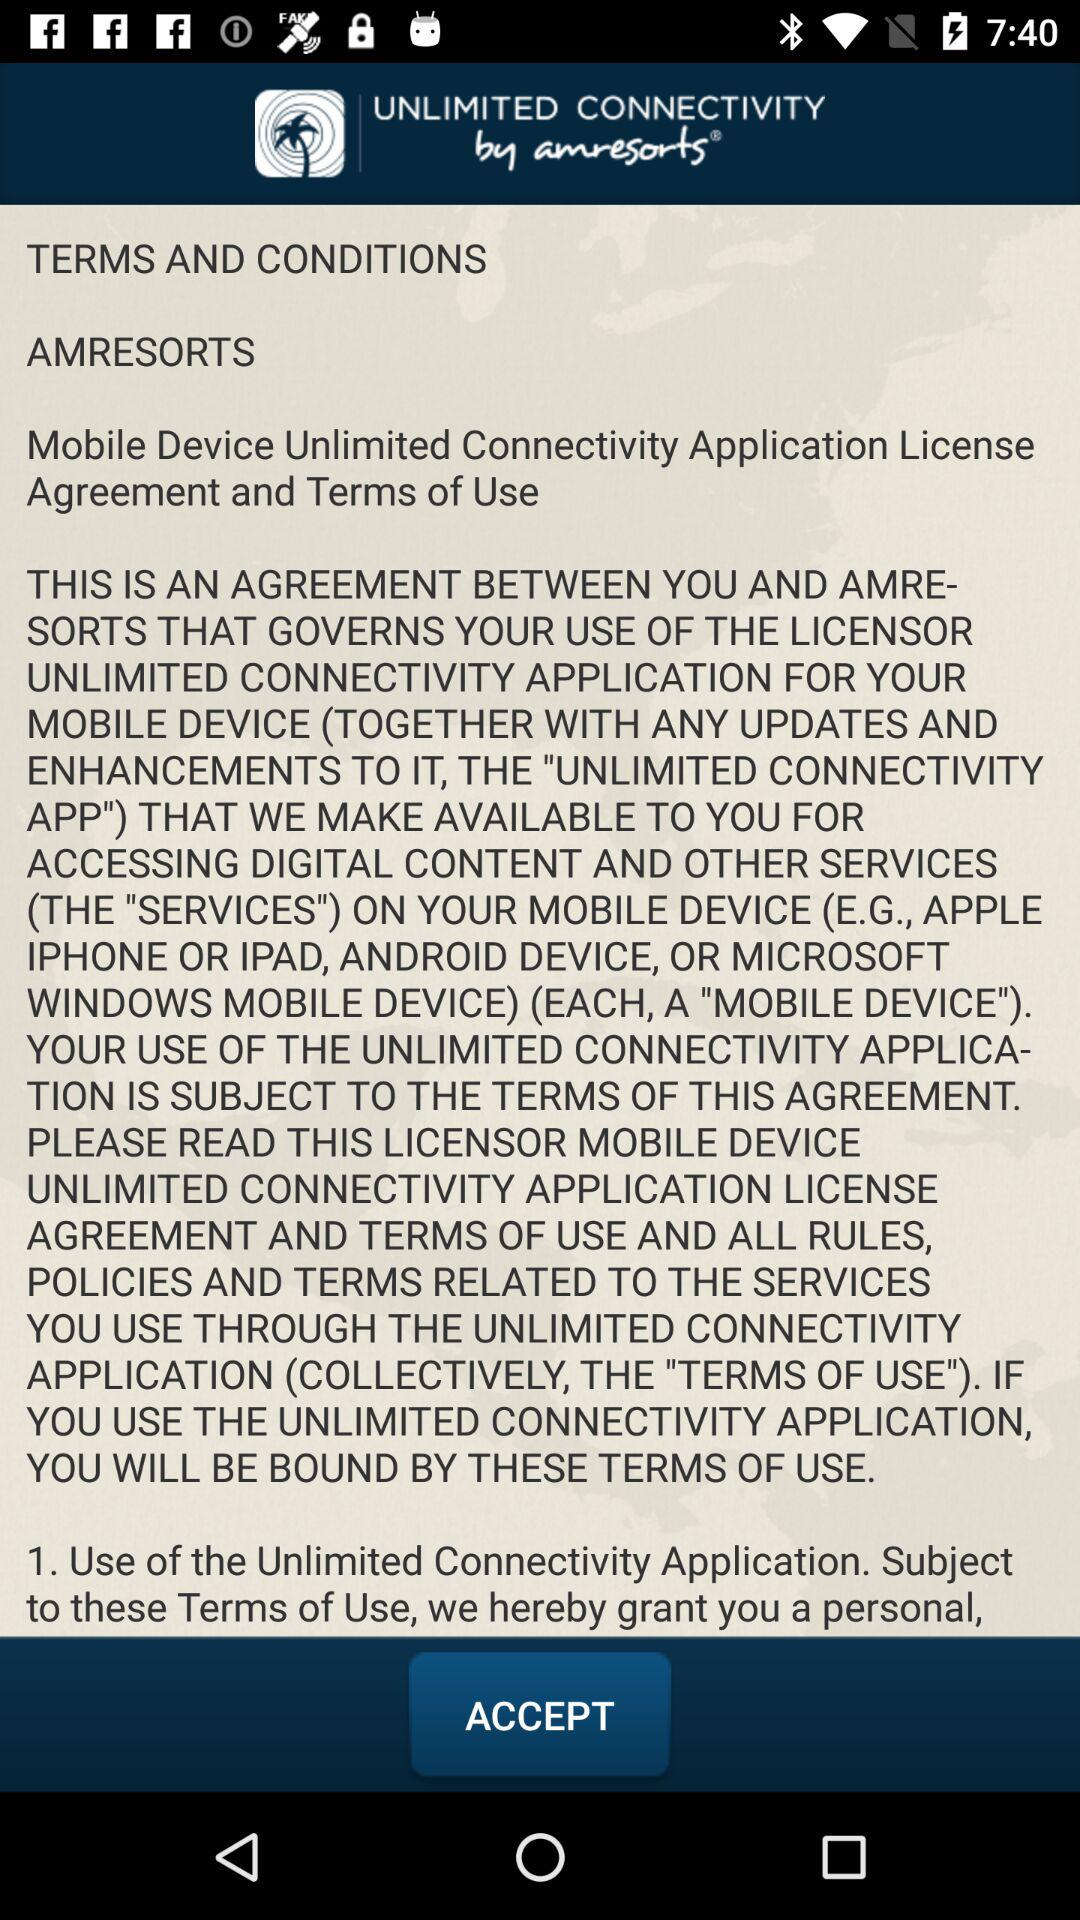What is the app name? The app name is "UNLIMITED CONNECTIVITY". 